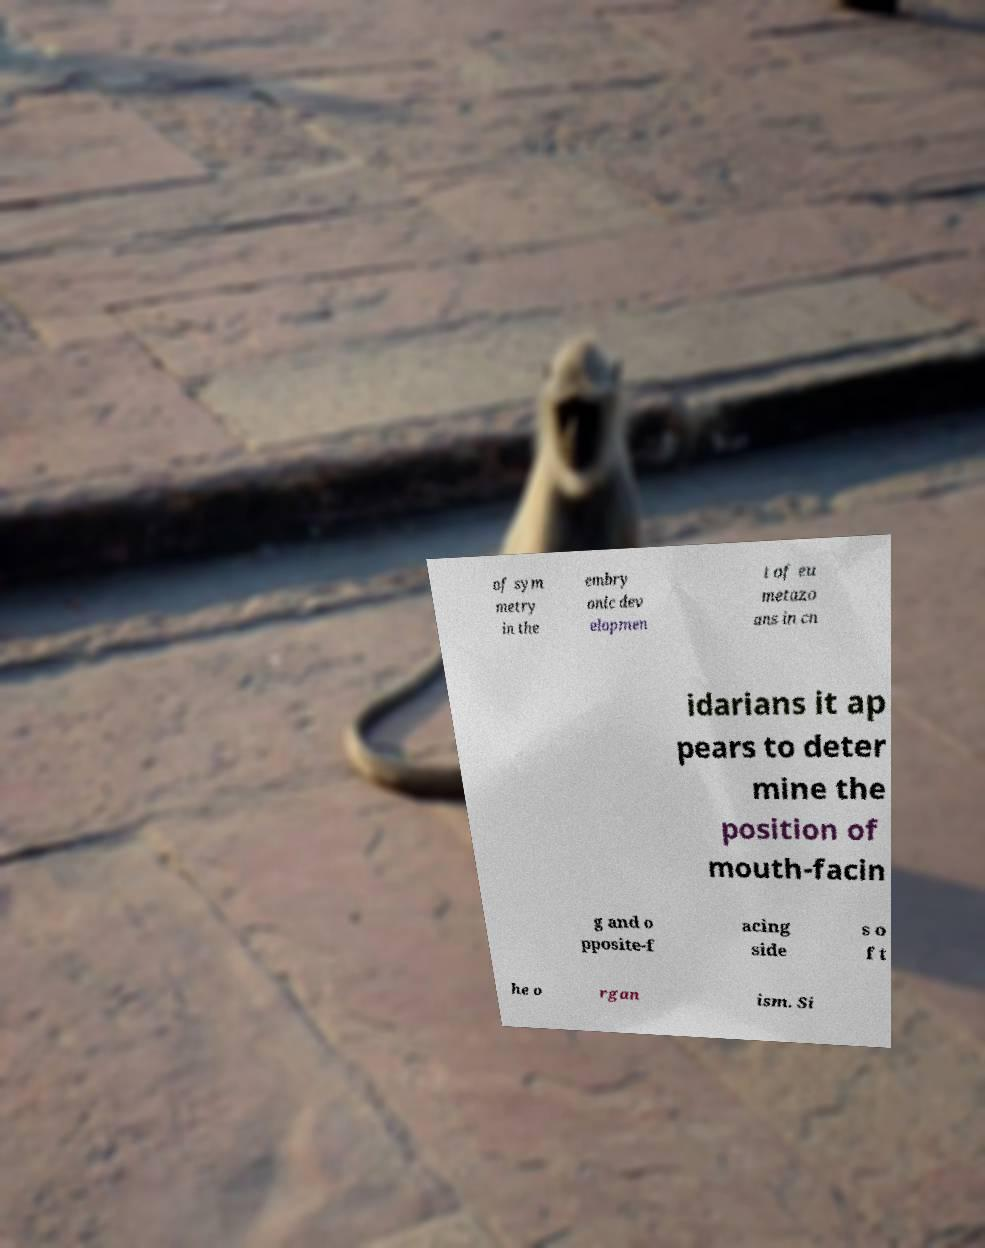Could you extract and type out the text from this image? of sym metry in the embry onic dev elopmen t of eu metazo ans in cn idarians it ap pears to deter mine the position of mouth-facin g and o pposite-f acing side s o f t he o rgan ism. Si 